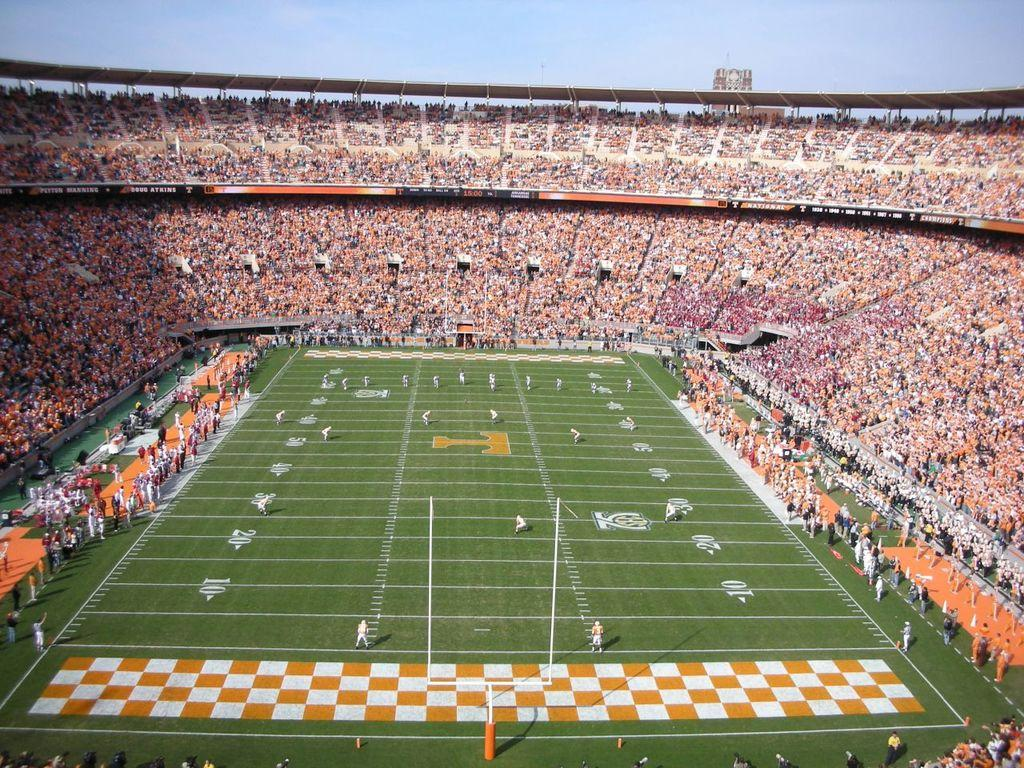<image>
Present a compact description of the photo's key features. players getting ready for kickoff at university of tennessee neyland stadium 